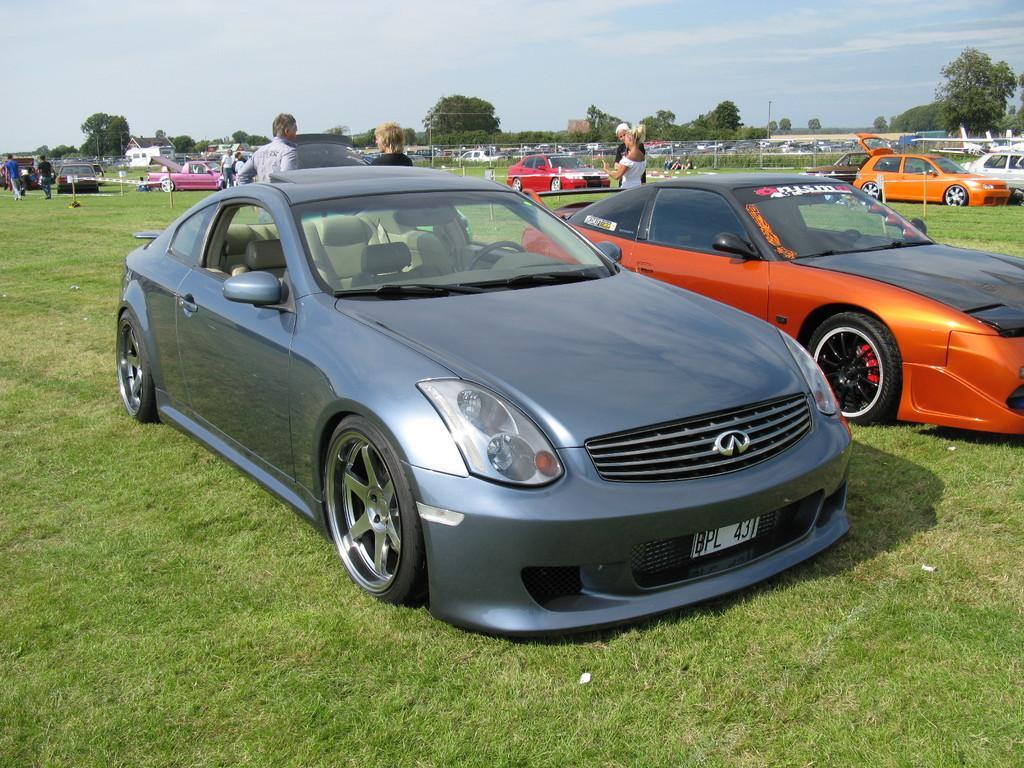Can you describe this image briefly? In this image I can see a car which is blue in color and another car which is orange and black in color is on the ground. In the background I can see few persons standing, few other cars on the ground, the fencing, few trees, few buildings and the sky. 